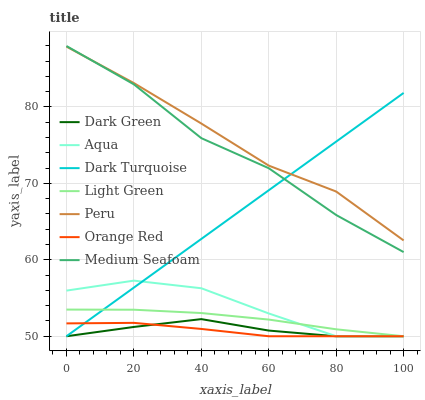Does Orange Red have the minimum area under the curve?
Answer yes or no. Yes. Does Peru have the maximum area under the curve?
Answer yes or no. Yes. Does Dark Turquoise have the minimum area under the curve?
Answer yes or no. No. Does Dark Turquoise have the maximum area under the curve?
Answer yes or no. No. Is Dark Turquoise the smoothest?
Answer yes or no. Yes. Is Medium Seafoam the roughest?
Answer yes or no. Yes. Is Aqua the smoothest?
Answer yes or no. No. Is Aqua the roughest?
Answer yes or no. No. Does Light Green have the lowest value?
Answer yes or no. Yes. Does Medium Seafoam have the lowest value?
Answer yes or no. No. Does Medium Seafoam have the highest value?
Answer yes or no. Yes. Does Dark Turquoise have the highest value?
Answer yes or no. No. Is Light Green less than Medium Seafoam?
Answer yes or no. Yes. Is Medium Seafoam greater than Orange Red?
Answer yes or no. Yes. Does Medium Seafoam intersect Dark Turquoise?
Answer yes or no. Yes. Is Medium Seafoam less than Dark Turquoise?
Answer yes or no. No. Is Medium Seafoam greater than Dark Turquoise?
Answer yes or no. No. Does Light Green intersect Medium Seafoam?
Answer yes or no. No. 